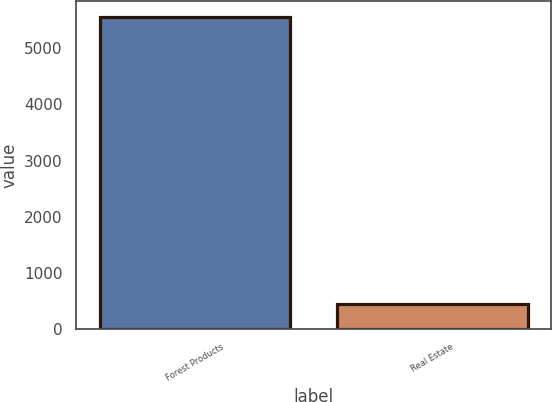<chart> <loc_0><loc_0><loc_500><loc_500><bar_chart><fcel>Forest Products<fcel>Real Estate<nl><fcel>5560<fcel>456<nl></chart> 